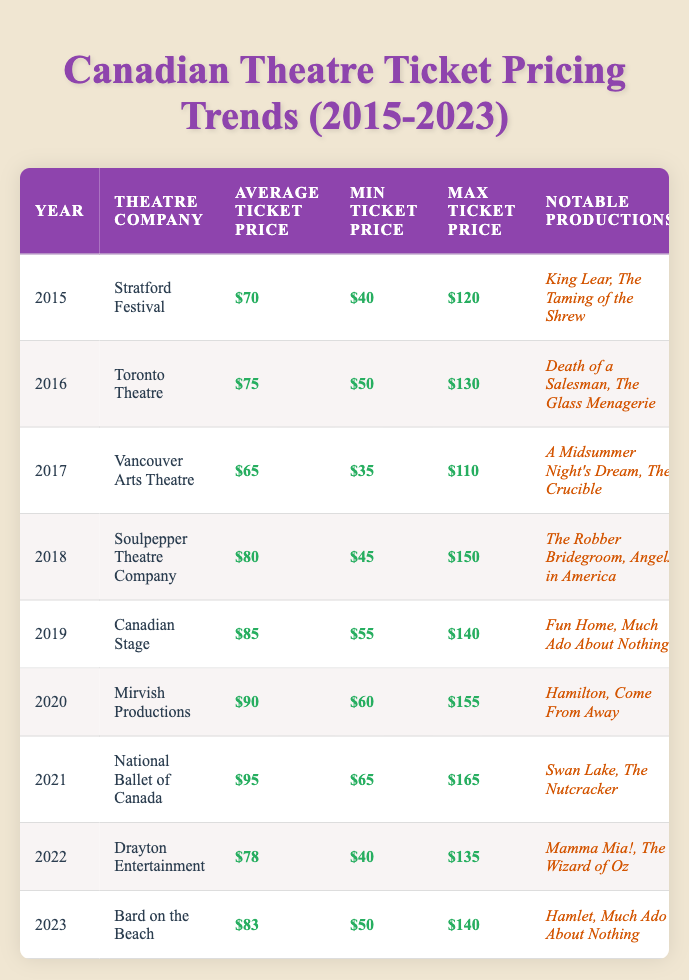What was the average ticket price for theatre productions in 2019? In the table, the average ticket price listed for 2019 under Canadian Stage is $85.
Answer: $85 Which theatre company had the highest average ticket price in 2021? The highest average ticket price in 2021 is from the National Ballet of Canada, which is $95.
Answer: National Ballet of Canada What is the difference between the maximum ticket price in 2020 and the minimum ticket price in 2017? The maximum ticket price in 2020 was $155, and the minimum ticket price in 2017 was $35. The difference is $155 - $35 = $120.
Answer: $120 Did the average ticket price decrease from 2017 to 2018? In 2017, the average ticket price was $65, and in 2018, it rose to $80. Therefore, it did not decrease.
Answer: No What is the trend in average ticket prices from 2015 to 2023? The average ticket prices increased from $70 in 2015 to $95 in 2021, then decreased to $78 in 2022, and increased slightly to $83 in 2023. Overall, there is a general upward trend but with some fluctuations.
Answer: Generally increasing with fluctuations What was the minimum ticket price recorded in 2020? The minimum ticket price for Mirvish Productions in 2020 was $60 as stated in the table.
Answer: $60 How much did the maximum ticket price rise from the lowest value in 2015 to the highest value in 2021? The maximum ticket price in 2015 was $120, and in 2021, it was $165. The rise is $165 - $120 = $45.
Answer: $45 What notable productions were shown by the Vancouver Arts Theatre in 2017? The notable productions for Vancouver Arts Theatre in 2017 include "A Midsummer Night's Dream" and "The Crucible."
Answer: A Midsummer Night's Dream, The Crucible Was the average ticket price for the Stratford Festival in 2015 lower than that of the Toronto Theatre in 2016? The average ticket price for Stratford Festival in 2015 was $70, which is lower than the $75 of Toronto Theatre in 2016.
Answer: Yes Calculate the average of average ticket prices from 2015 to 2023. The average ticket prices are $70 (2015), $75 (2016), $65 (2017), $80 (2018), $85 (2019), $90 (2020), $95 (2021), $78 (2022), $83 (2023). The total is $70 + $75 + $65 + $80 + $85 + $90 + $95 + $78 + $83 = $823. There are 9 years, so the average is $823 / 9 ≈ $91.44.
Answer: Approximately $91.44 